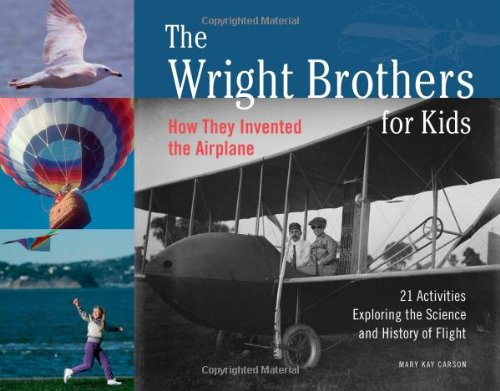Is this a kids book? Yes, this book is explicitly tailored for children, as indicated by its engaging design and educational content aimed to inspire young minds about the history of flight and inventions. 